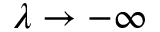Convert formula to latex. <formula><loc_0><loc_0><loc_500><loc_500>\lambda \to - \infty</formula> 